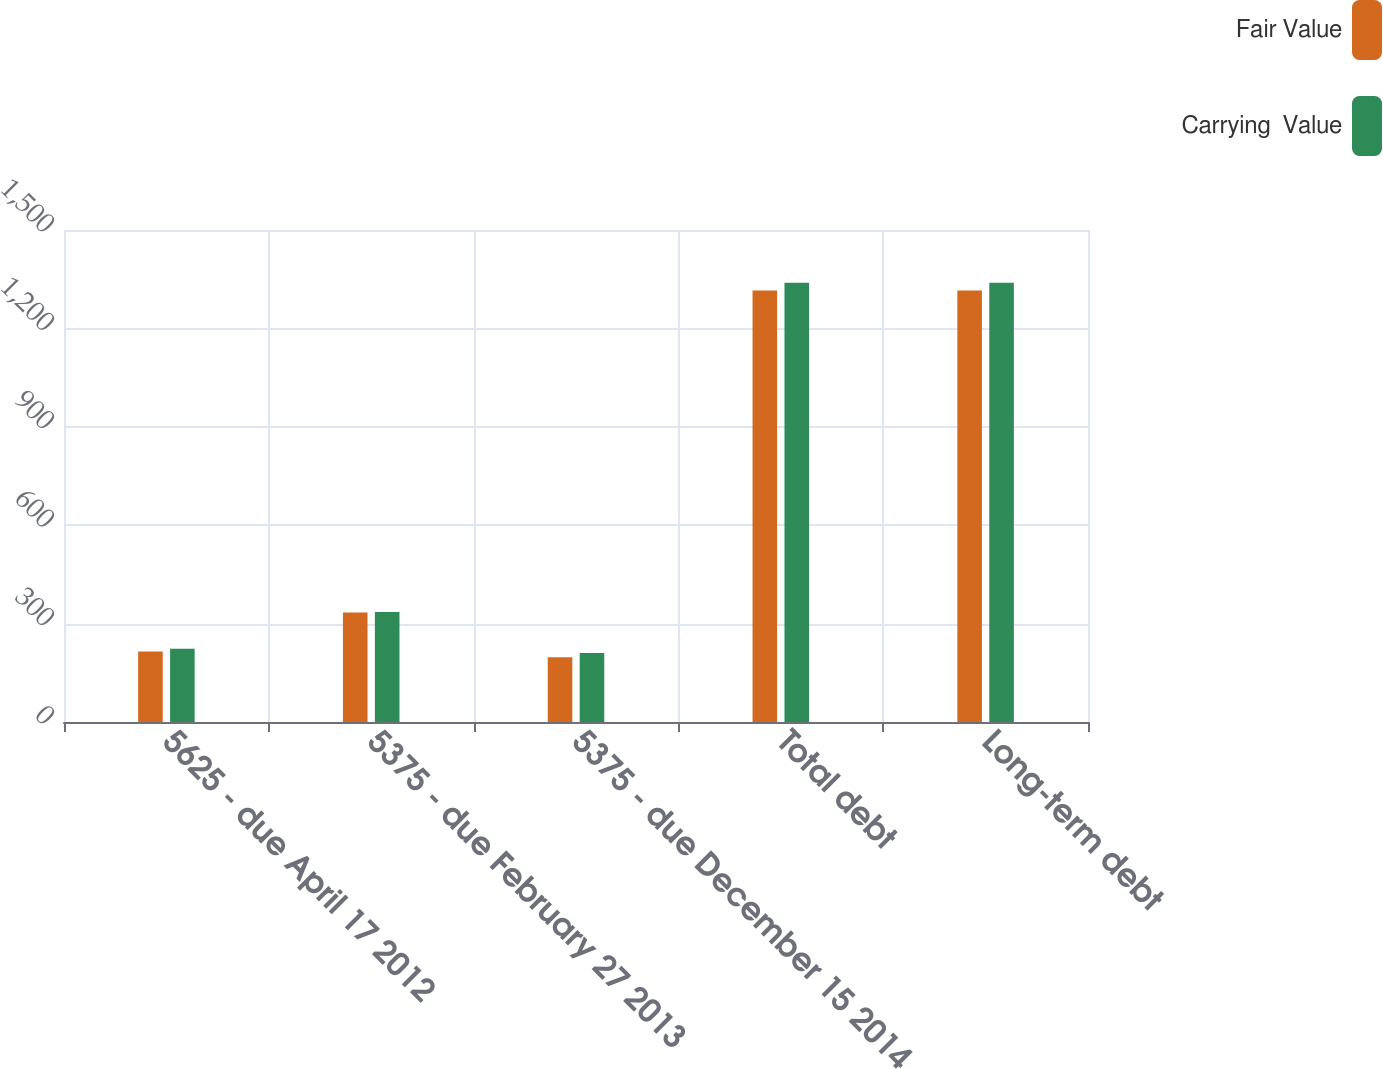<chart> <loc_0><loc_0><loc_500><loc_500><stacked_bar_chart><ecel><fcel>5625 - due April 17 2012<fcel>5375 - due February 27 2013<fcel>5375 - due December 15 2014<fcel>Total debt<fcel>Long-term debt<nl><fcel>Fair Value<fcel>215.1<fcel>333.5<fcel>197.1<fcel>1315.7<fcel>1315.7<nl><fcel>Carrying  Value<fcel>223.7<fcel>335.2<fcel>210.4<fcel>1339.3<fcel>1339.3<nl></chart> 